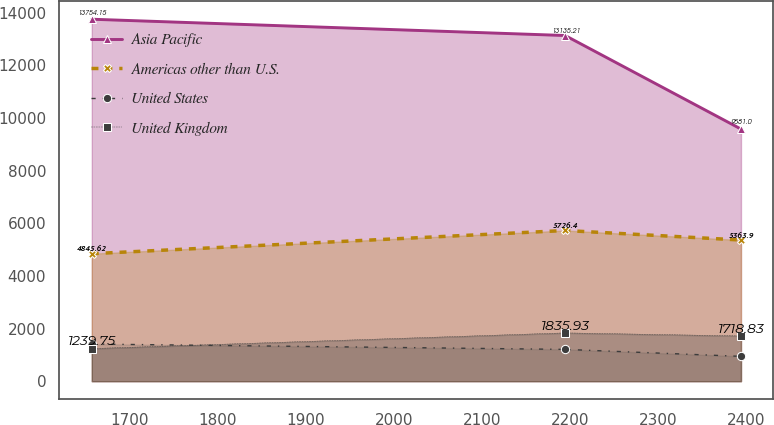Convert chart to OTSL. <chart><loc_0><loc_0><loc_500><loc_500><line_chart><ecel><fcel>Asia Pacific<fcel>Americas other than U.S.<fcel>United States<fcel>United Kingdom<nl><fcel>1656.81<fcel>13754.1<fcel>4845.62<fcel>1412.51<fcel>1239.75<nl><fcel>2194.77<fcel>13135.2<fcel>5726.4<fcel>1209.28<fcel>1835.93<nl><fcel>2394.61<fcel>9581<fcel>5363.9<fcel>944.58<fcel>1718.83<nl></chart> 